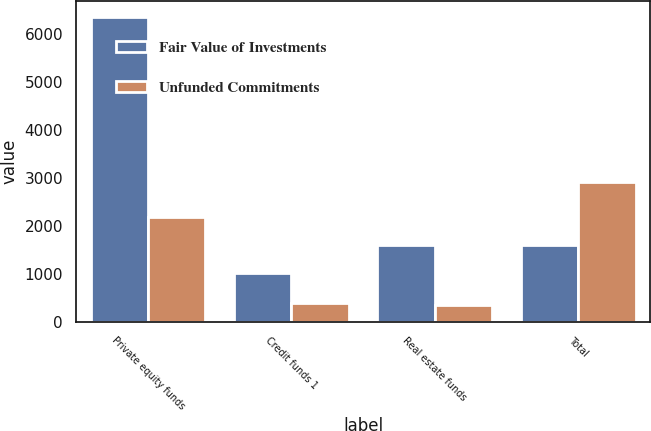Convert chart to OTSL. <chart><loc_0><loc_0><loc_500><loc_500><stacked_bar_chart><ecel><fcel>Private equity funds<fcel>Credit funds 1<fcel>Real estate funds<fcel>Total<nl><fcel>Fair Value of Investments<fcel>6356<fcel>1021<fcel>1604<fcel>1604<nl><fcel>Unfunded Commitments<fcel>2181<fcel>390<fcel>344<fcel>2915<nl></chart> 